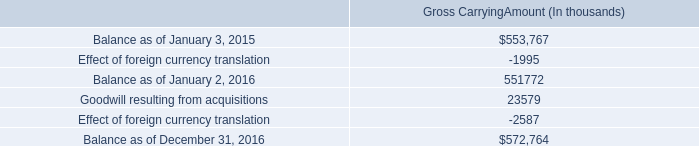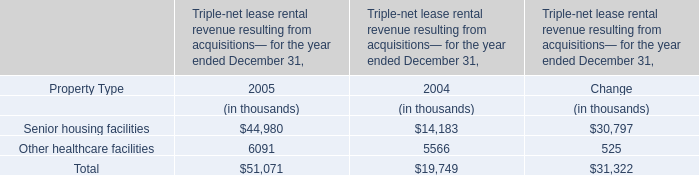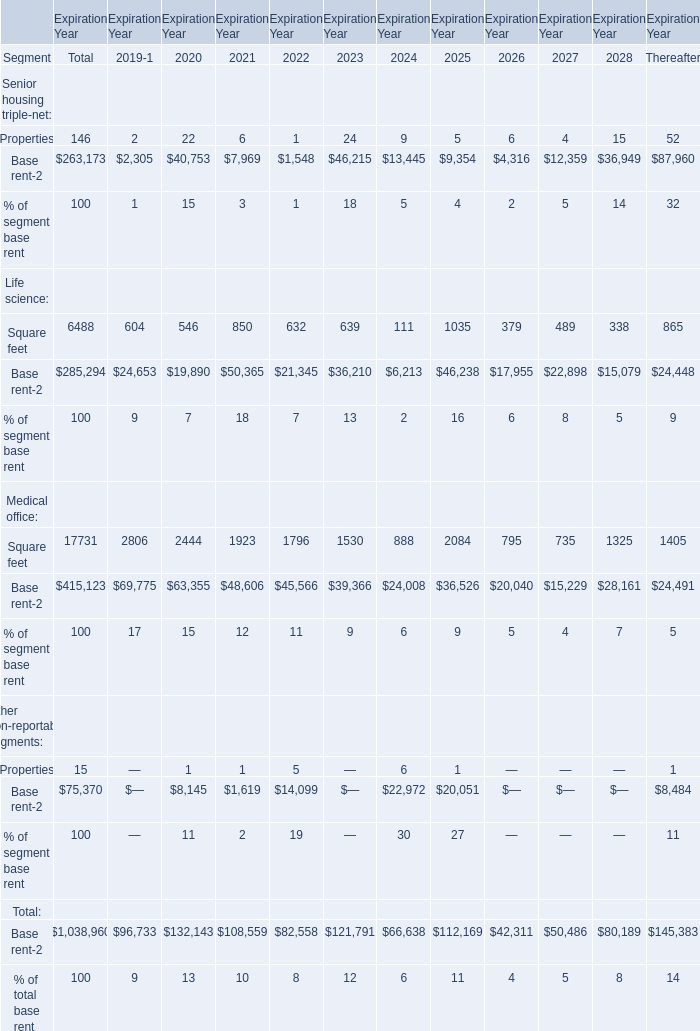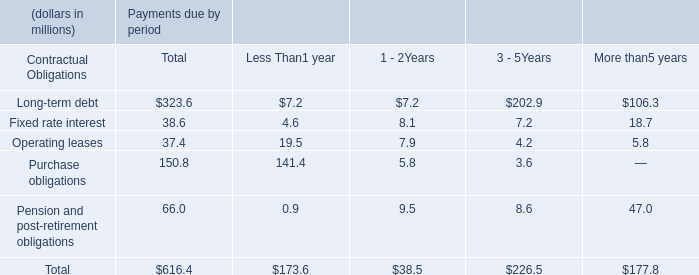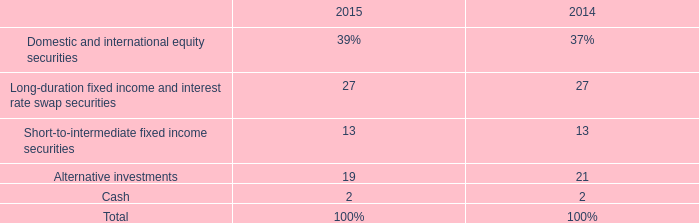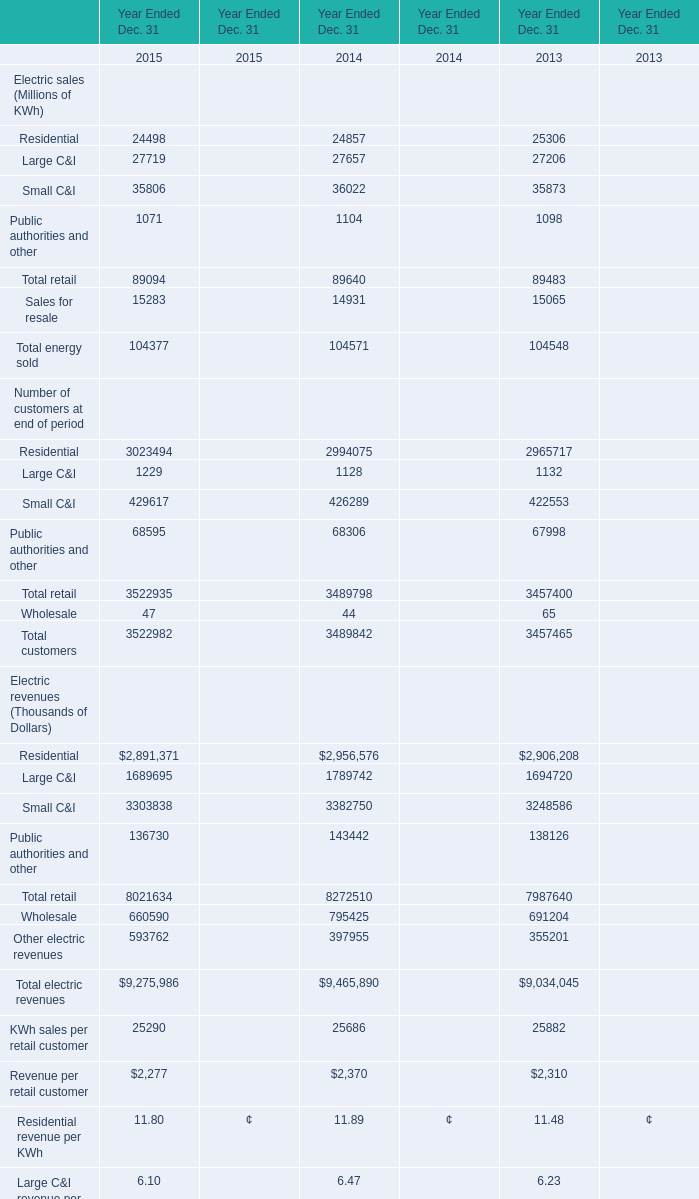what is the percentage increase in gross carrying amount from the beginning of 2015 to the end of 2016? 
Computations: ((572764 - 553767) / 553767)
Answer: 0.03431. 